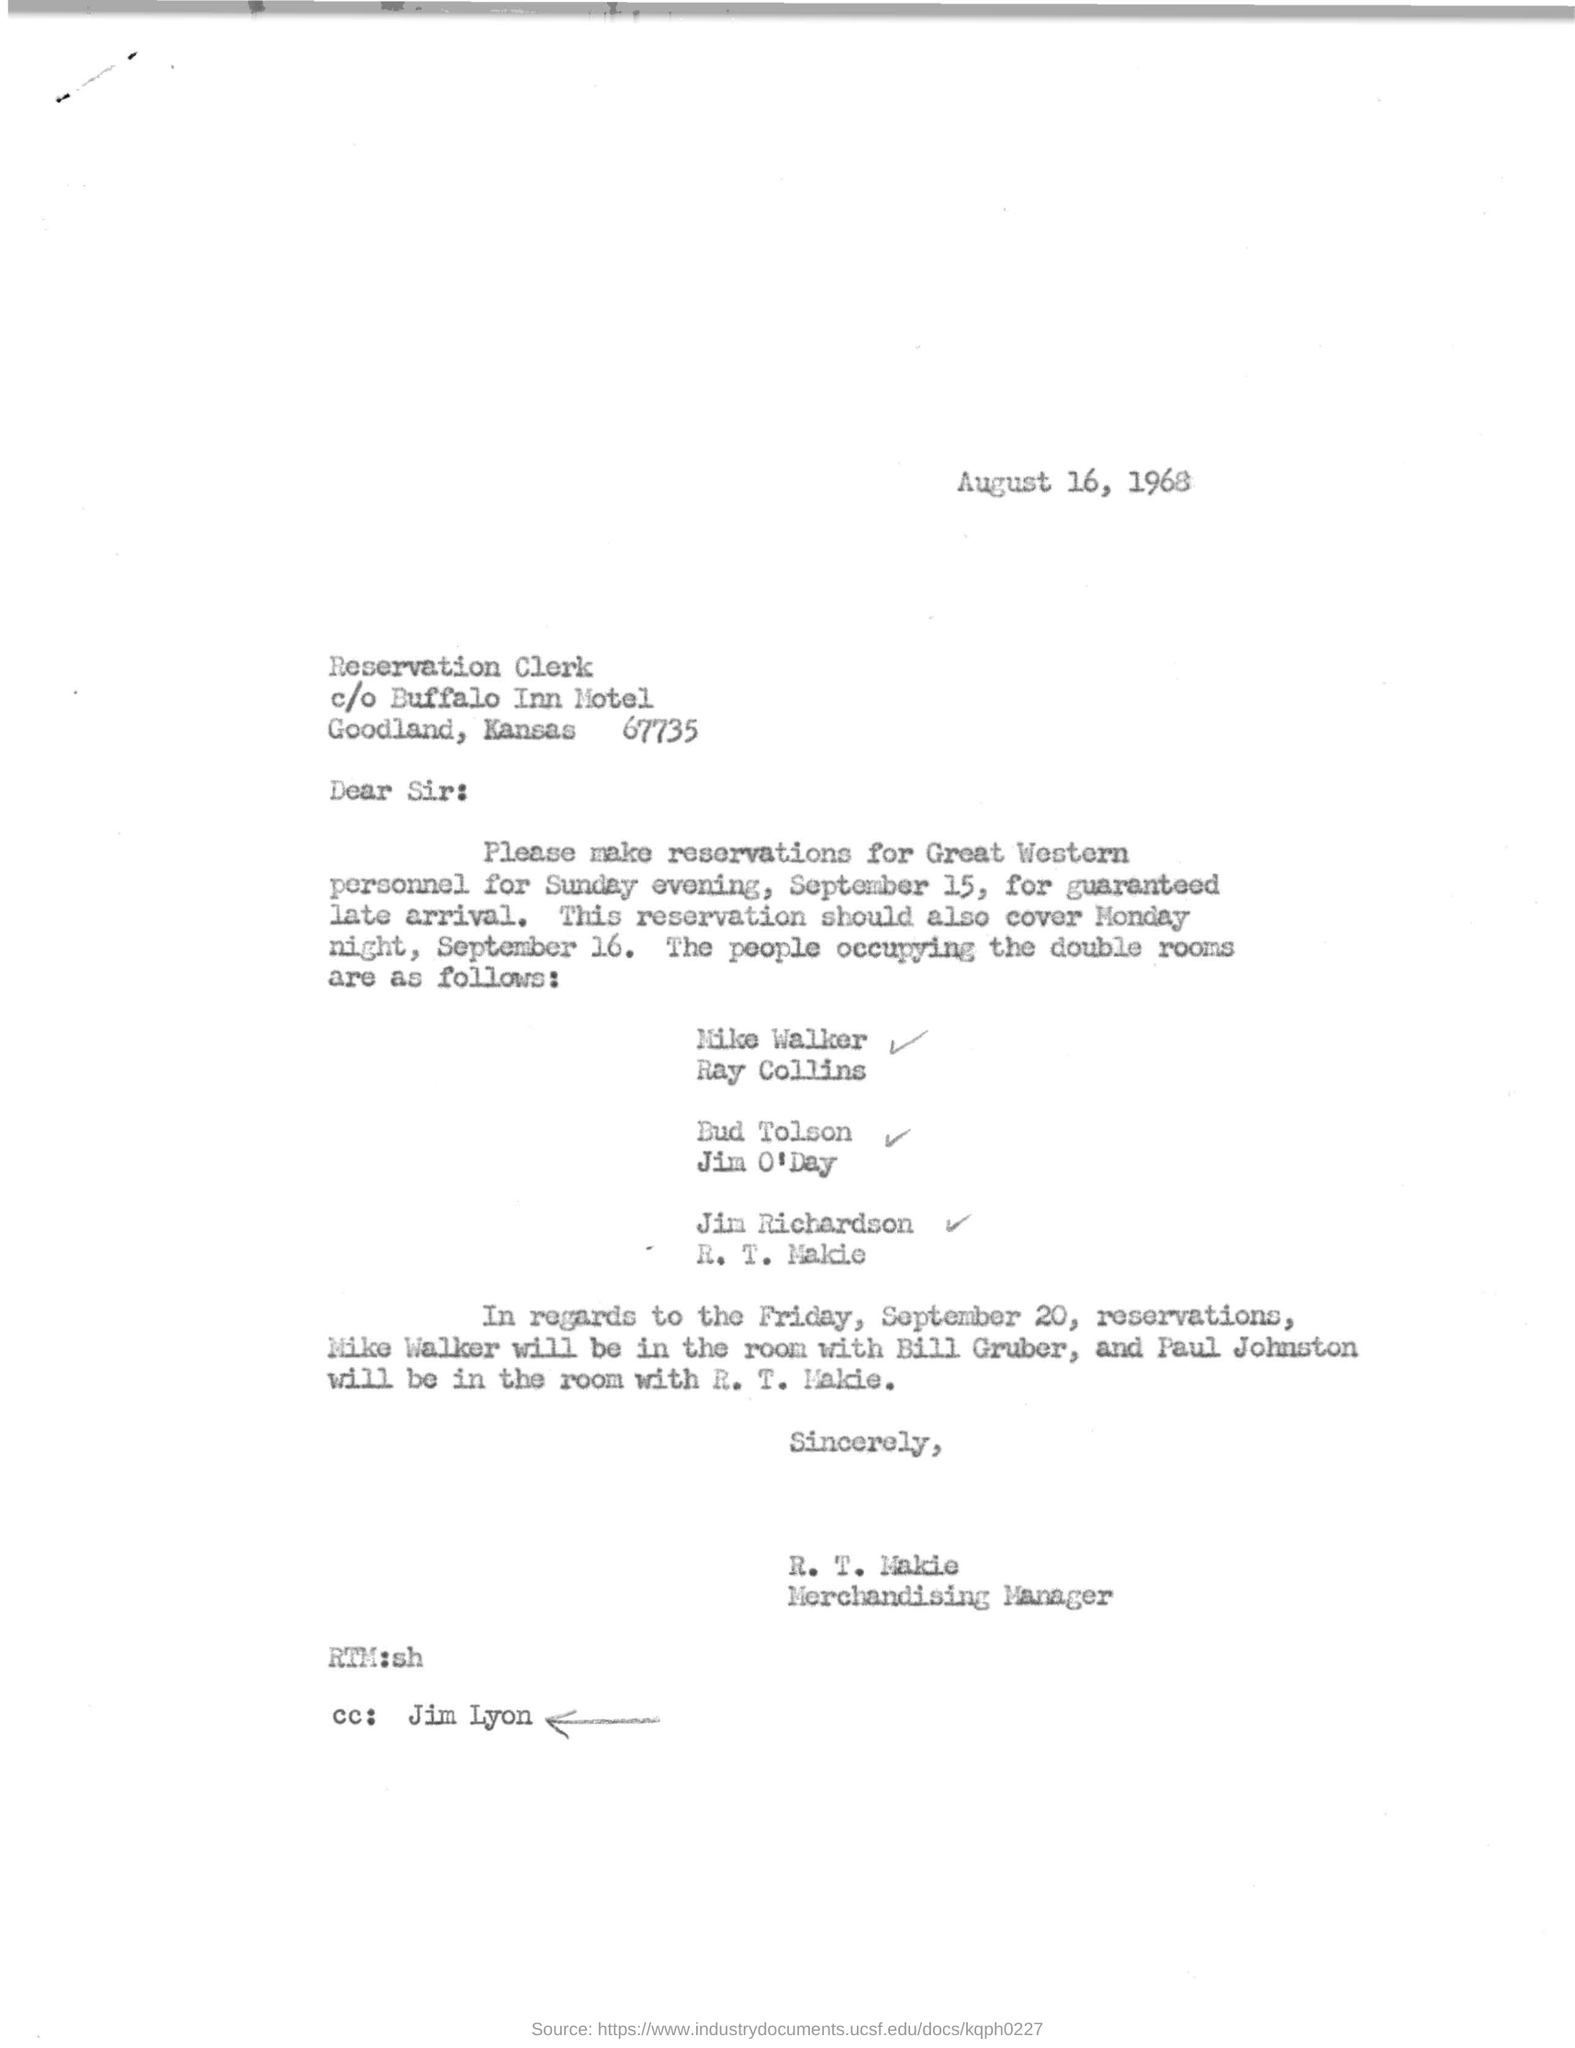What is the letter dated?
Keep it short and to the point. August 16, 1968. Who is the sender of this letter?
Offer a terse response. R. T. Makie. What is the designation of R. T. Makie ?
Your answer should be very brief. Merchandising Manager. Who is mentioned in the cc?
Your response must be concise. Jim Lyon. 